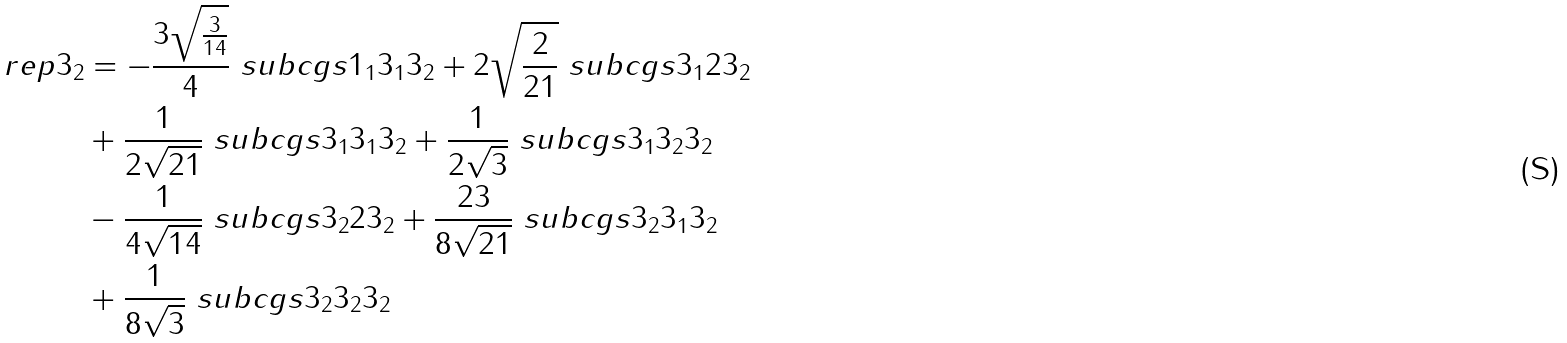<formula> <loc_0><loc_0><loc_500><loc_500>\ r e p { 3 } _ { 2 } & = - \frac { 3 \sqrt { \frac { 3 } { 1 4 } } } { 4 } \ s u b c g s { 1 _ { 1 } } { 3 _ { 1 } } { 3 _ { 2 } } + 2 \sqrt { \frac { 2 } { 2 1 } } \ s u b c g s { 3 _ { 1 } } { 2 } { 3 _ { 2 } } \\ & + \frac { 1 } { 2 \sqrt { 2 1 } } \ s u b c g s { 3 _ { 1 } } { 3 _ { 1 } } { 3 _ { 2 } } + \frac { 1 } { 2 \sqrt { 3 } } \ s u b c g s { 3 _ { 1 } } { 3 _ { 2 } } { 3 _ { 2 } } \\ & - \frac { 1 } { 4 \sqrt { 1 4 } } \ s u b c g s { 3 _ { 2 } } { 2 } { 3 _ { 2 } } + \frac { 2 3 } { 8 \sqrt { 2 1 } } \ s u b c g s { 3 _ { 2 } } { 3 _ { 1 } } { 3 _ { 2 } } \\ & + \frac { 1 } { 8 \sqrt { 3 } } \ s u b c g s { 3 _ { 2 } } { 3 _ { 2 } } { 3 _ { 2 } }</formula> 